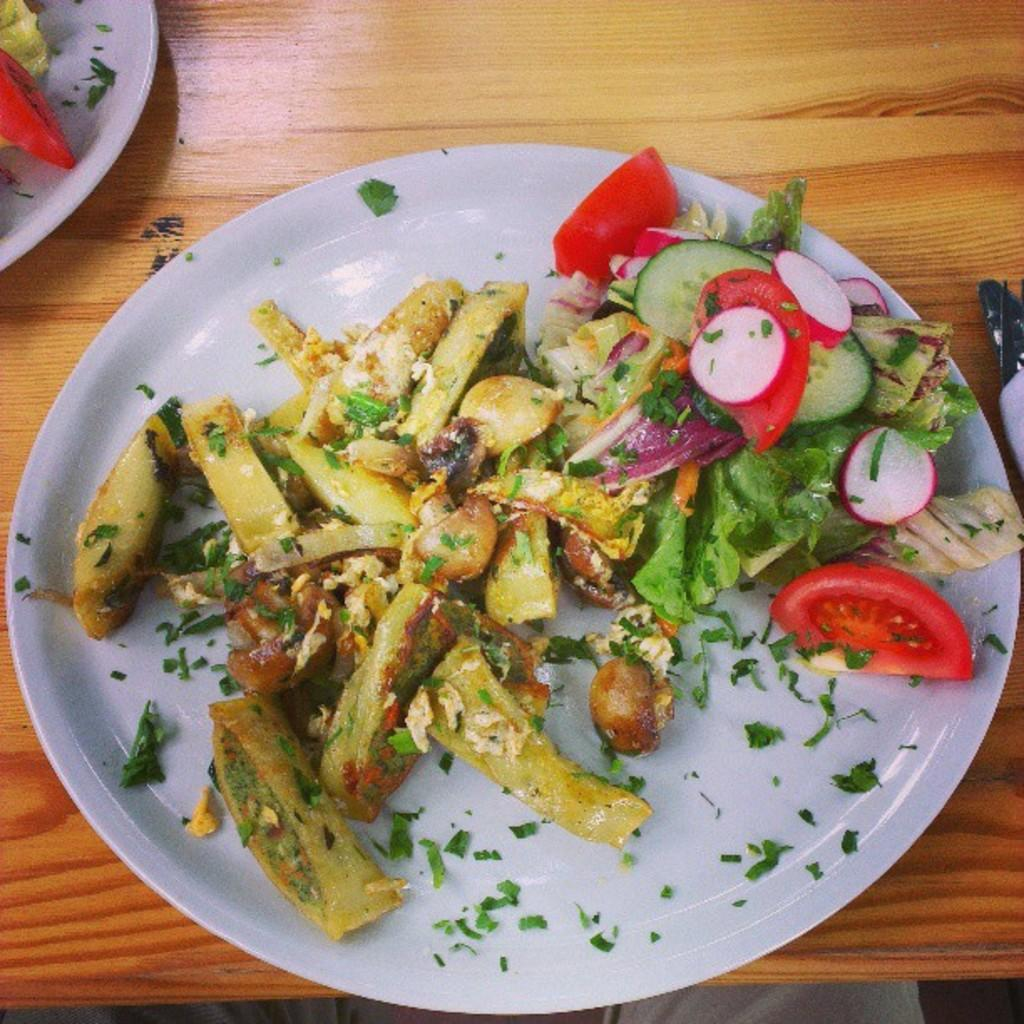What is the main piece of furniture in the image? There is a table in the image. What is on the table in the image? The table has plates containing food. Can you describe any other elements in the image? A person's legs are visible at the bottom of the image. What type of pain is the person experiencing in the image? There is no indication of pain in the image; only a table with plates containing food and a person's legs are visible. 